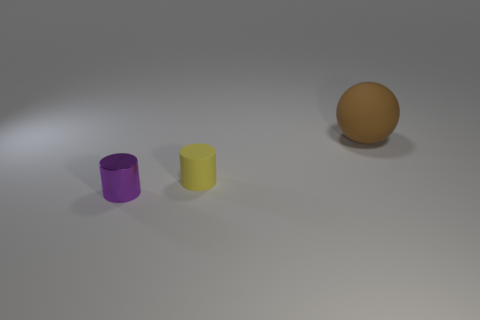Compare the size of the cylinders to the sphere. Both cylinders are shorter in height than the diameter of the sphere, with the purple one being slightly taller than the yellow. The width of the cylinders appears to be less than the sphere's diameter as well. 